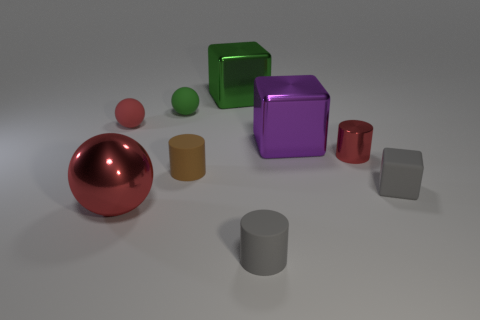Does the big object on the right side of the tiny gray cylinder have the same shape as the big metallic thing in front of the purple shiny object?
Give a very brief answer. No. The cube that is both behind the tiny gray rubber block and in front of the small green ball is what color?
Make the answer very short. Purple. There is a matte block; does it have the same color as the tiny ball left of the large metallic ball?
Give a very brief answer. No. There is a cylinder that is in front of the red metallic cylinder and behind the red metallic sphere; how big is it?
Provide a succinct answer. Small. What number of other objects are there of the same color as the large shiny sphere?
Your answer should be compact. 2. There is a red metallic thing that is right of the tiny gray rubber thing that is in front of the tiny block that is in front of the tiny brown matte cylinder; what is its size?
Offer a terse response. Small. There is a small red sphere; are there any tiny green objects left of it?
Provide a succinct answer. No. Does the red cylinder have the same size as the block that is in front of the shiny cylinder?
Make the answer very short. Yes. How many other objects are there of the same material as the gray cube?
Offer a terse response. 4. What is the shape of the object that is to the left of the gray rubber block and to the right of the big purple thing?
Your answer should be compact. Cylinder. 